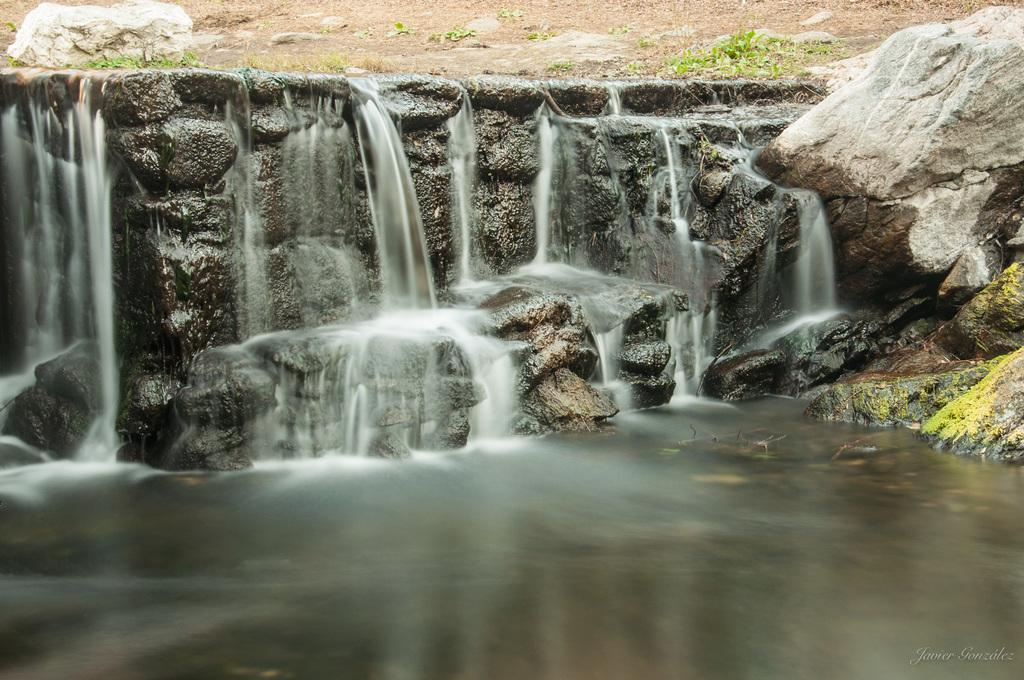What is the main element in the image? There is water in the image. What feature can be seen within the water? There is a small waterfall in the image. What type of natural objects are visible in the water? Stones are visible in the image. What type of vegetation is present in the image? There are plants in the image. What can be seen in the background of the image? There is an open ground in the background of the image. What type of instrument is being played by the goldfish in the image? There is no goldfish or instrument present in the image. How does the tramp contribute to the overall scene in the image? There is no tramp present in the image. 